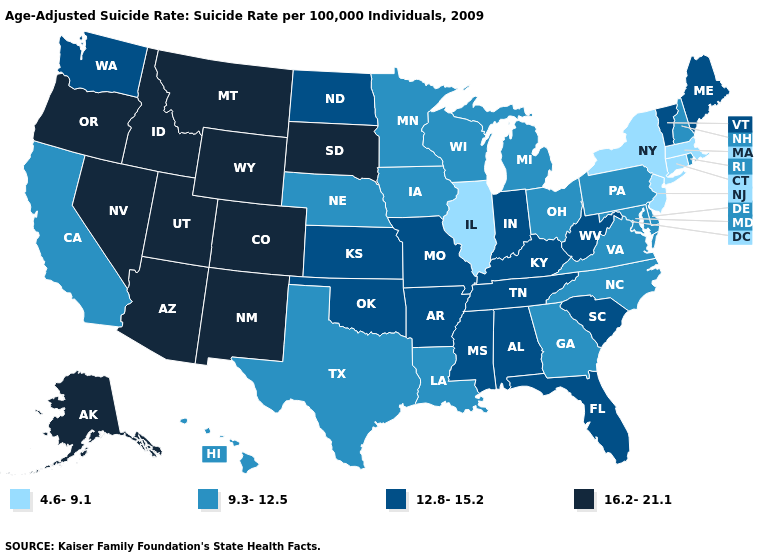Does Utah have a higher value than Illinois?
Give a very brief answer. Yes. Does Ohio have the lowest value in the USA?
Give a very brief answer. No. Among the states that border North Carolina , which have the lowest value?
Concise answer only. Georgia, Virginia. What is the highest value in the MidWest ?
Keep it brief. 16.2-21.1. Among the states that border Louisiana , which have the highest value?
Write a very short answer. Arkansas, Mississippi. Among the states that border Iowa , does Wisconsin have the lowest value?
Answer briefly. No. Does Louisiana have the lowest value in the South?
Give a very brief answer. Yes. Does California have the lowest value in the West?
Answer briefly. Yes. Which states have the highest value in the USA?
Short answer required. Alaska, Arizona, Colorado, Idaho, Montana, Nevada, New Mexico, Oregon, South Dakota, Utah, Wyoming. Name the states that have a value in the range 16.2-21.1?
Answer briefly. Alaska, Arizona, Colorado, Idaho, Montana, Nevada, New Mexico, Oregon, South Dakota, Utah, Wyoming. What is the highest value in states that border Arizona?
Quick response, please. 16.2-21.1. What is the highest value in the Northeast ?
Keep it brief. 12.8-15.2. What is the value of Minnesota?
Write a very short answer. 9.3-12.5. Which states hav the highest value in the MidWest?
Concise answer only. South Dakota. 